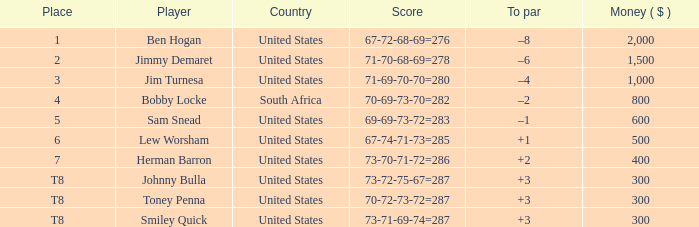What is the To par of the 4 Place Player? –2. 